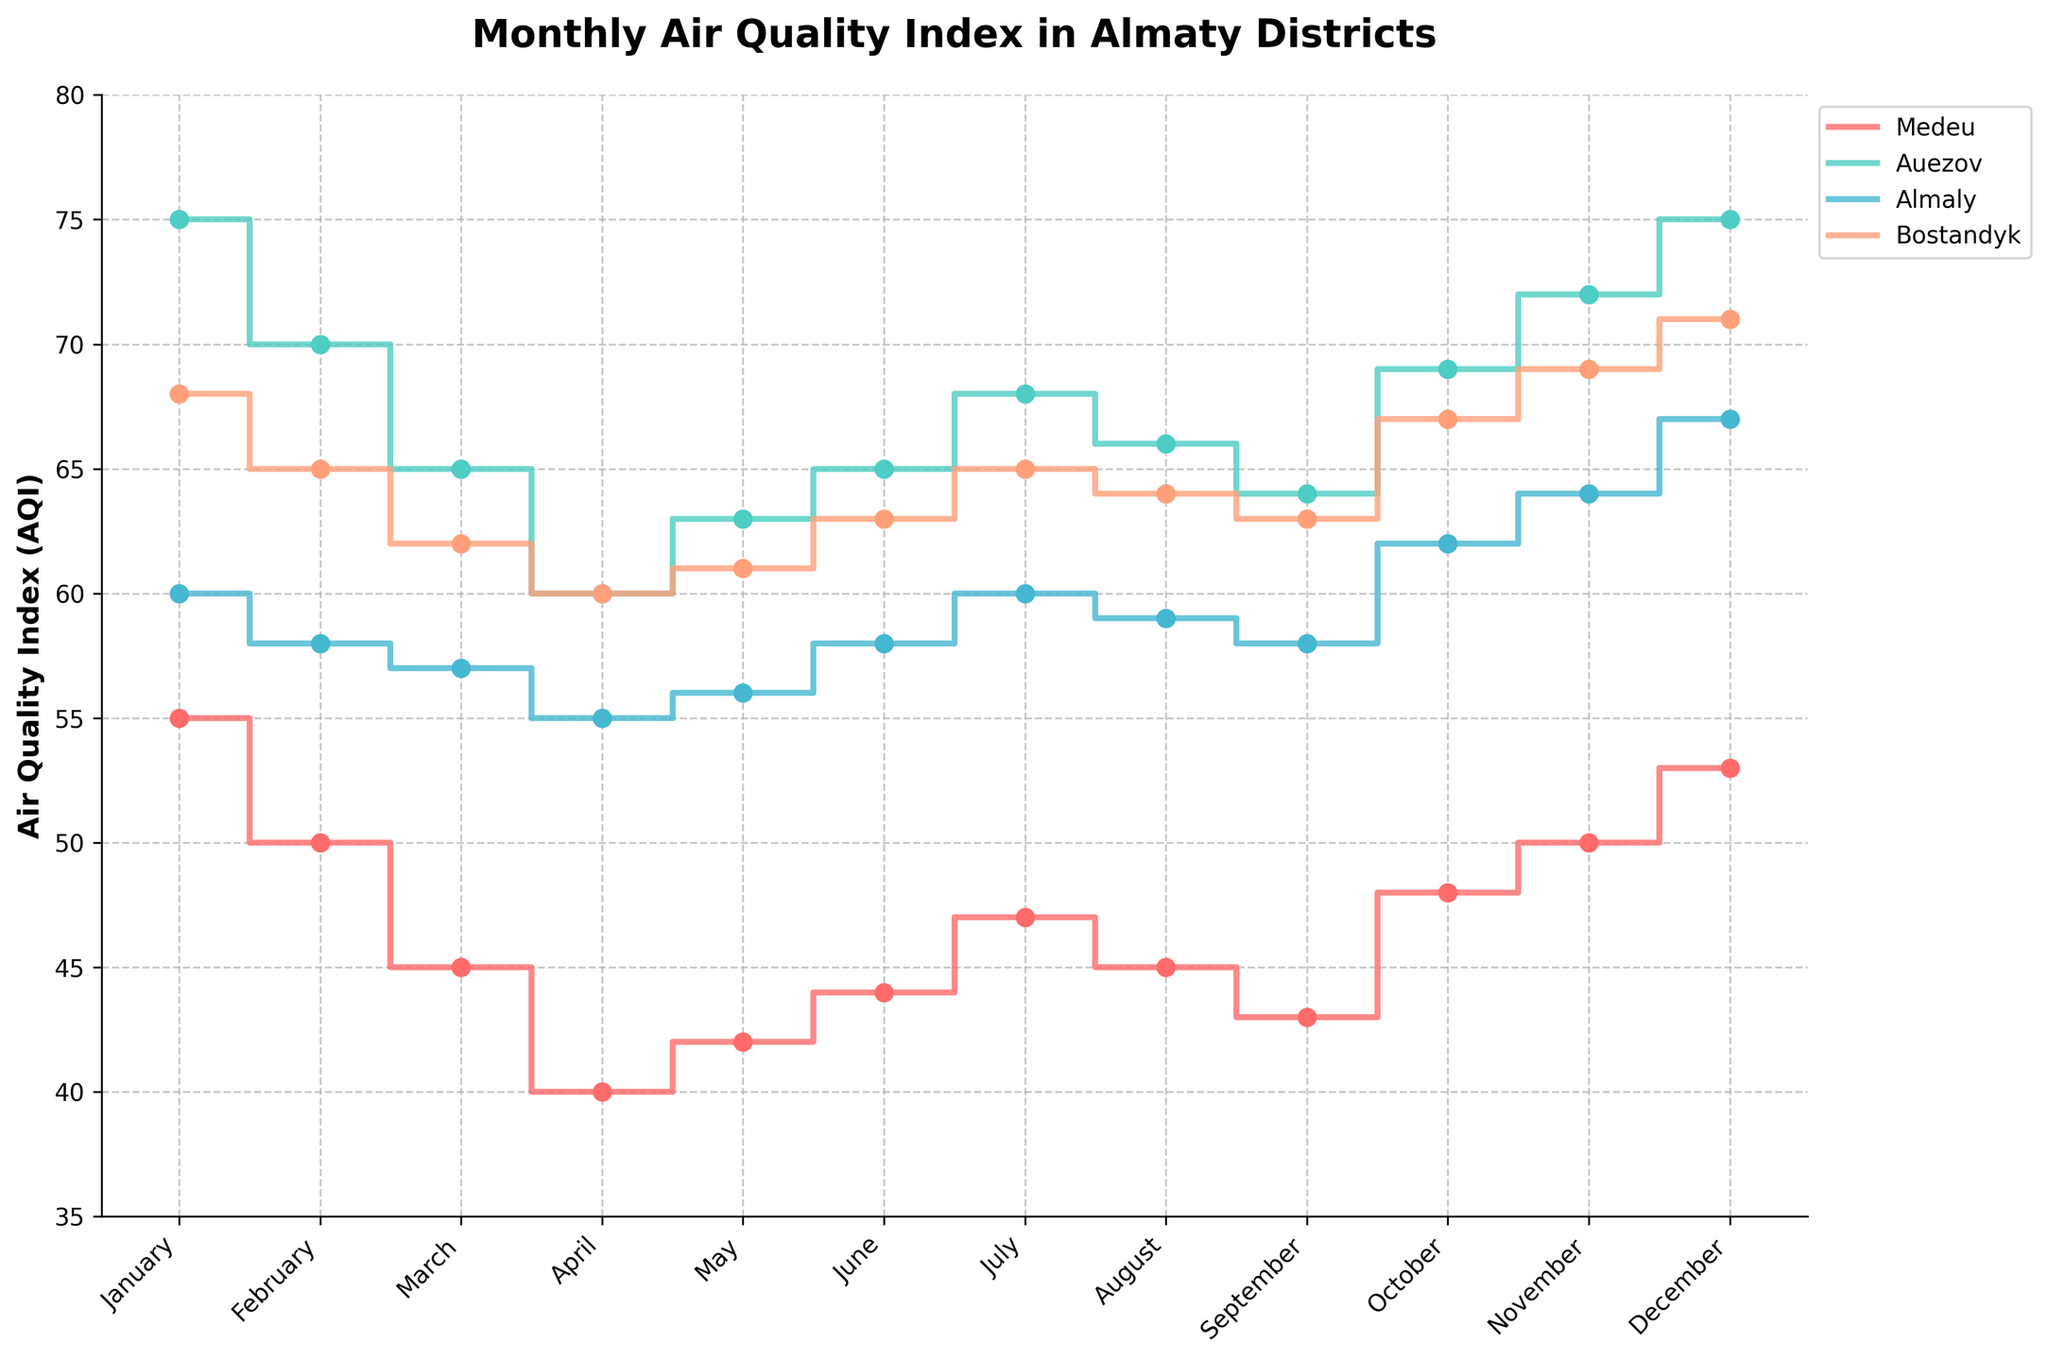Which district has the highest AQI in December? December has AQI data points for all four districts. Medeu has 53, Auezov has 75, Almaly has 67, and Bostandyk has 71. The highest value among these is 75 (Auezov).
Answer: Auezov What is the title of the plot? The title of the plot is located at the top of the figure. It reads "Monthly Air Quality Index in Almaty Districts."
Answer: Monthly Air Quality Index in Almaty Districts What is the trend of AQI in Medeu across the months? By looking at the AQI values for Medeu from January to December, you can observe that the AQI decreases from January (55) to a low point in April (40), slightly increases in May (42), June (44), July (47), decreases slightly in August (45), then continues to increase until it reaches 53 in December.
Answer: Decreases from January to April, then generally increases to December Which month has the lowest AQI reading in Auezov? Observing the AQI values for Auezov across the months, January (75), February (70), March (65), April (60), May (63), June (65), July (68), August (66), September (64), October (69), November (72), and December (75), the lowest AQI reading is in April with 60.
Answer: April Compare the AQI trends in Almaly and Bostandyk from January to June. For Almaly, the AQI drops from 60 in January to a low of 55 in April, and then rises to 58 in June. For Bostandyk, the AQI drops from 68 in January to 60 in April, and then rises to 63 in June. Both districts have a similar trend of decreasing from January to April and then increasing until June.
Answer: Both districts decrease from January to April, then increase to June What are the AQI values in Bostandyk for the months with exactly 61 AQI? The AQI values in Bostandyk are given for each month. By inspecting these, we see that May and June both have an AQI of 61.
Answer: May and June How does the AQI in October compare between all four districts? In October, the AQI values are Medeu (48), Auezov (69), Almaly (62), and Bostandyk (67). Auezov has the highest AQI and Medeu has the lowest AQI for October.
Answer: Auezov has the highest, and Medeu has the lowest What is the average AQI in Almaly for the first quarter (January to March)? The AQI for Almaly in January is 60, in February is 58, and in March is 57. The sum of these values is 60 +58 + 57 = 175. The average is 175/3 = 58.33
Answer: 58.33 Which district shows the most stable AQI across the year? Stability can be determined by looking at the fluctuation range of AQI values. Medeu ranges from 40 to 55, Auezov ranges from 60 to 75, Almaly ranges from 55 to 67, and Bostandyk ranges from 60 to 71. Medeu has the smallest range of 15 (55 - 40).
Answer: Medeu 